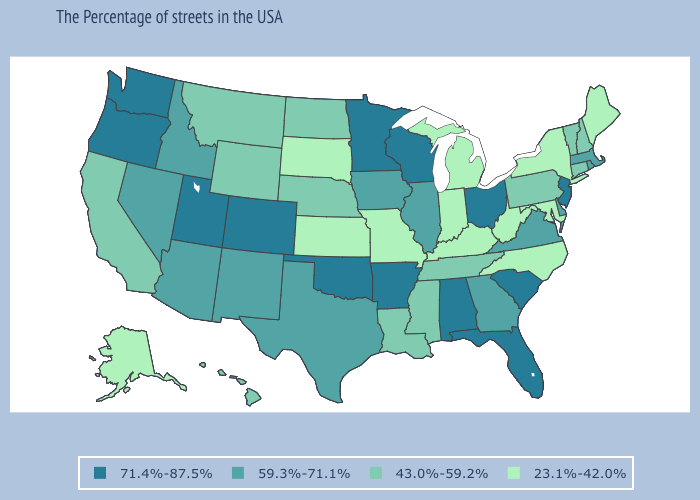What is the value of Alabama?
Keep it brief. 71.4%-87.5%. What is the value of Montana?
Concise answer only. 43.0%-59.2%. Is the legend a continuous bar?
Give a very brief answer. No. Which states hav the highest value in the West?
Give a very brief answer. Colorado, Utah, Washington, Oregon. Does Alaska have the same value as New Mexico?
Write a very short answer. No. Name the states that have a value in the range 71.4%-87.5%?
Quick response, please. New Jersey, South Carolina, Ohio, Florida, Alabama, Wisconsin, Arkansas, Minnesota, Oklahoma, Colorado, Utah, Washington, Oregon. Does South Carolina have the highest value in the South?
Keep it brief. Yes. Does North Dakota have the same value as Mississippi?
Quick response, please. Yes. Among the states that border Utah , does Arizona have the lowest value?
Keep it brief. No. Does Montana have a higher value than Alabama?
Short answer required. No. What is the highest value in states that border Delaware?
Give a very brief answer. 71.4%-87.5%. What is the value of Oregon?
Quick response, please. 71.4%-87.5%. Does North Carolina have the highest value in the South?
Keep it brief. No. What is the lowest value in the USA?
Be succinct. 23.1%-42.0%. Does the map have missing data?
Short answer required. No. 